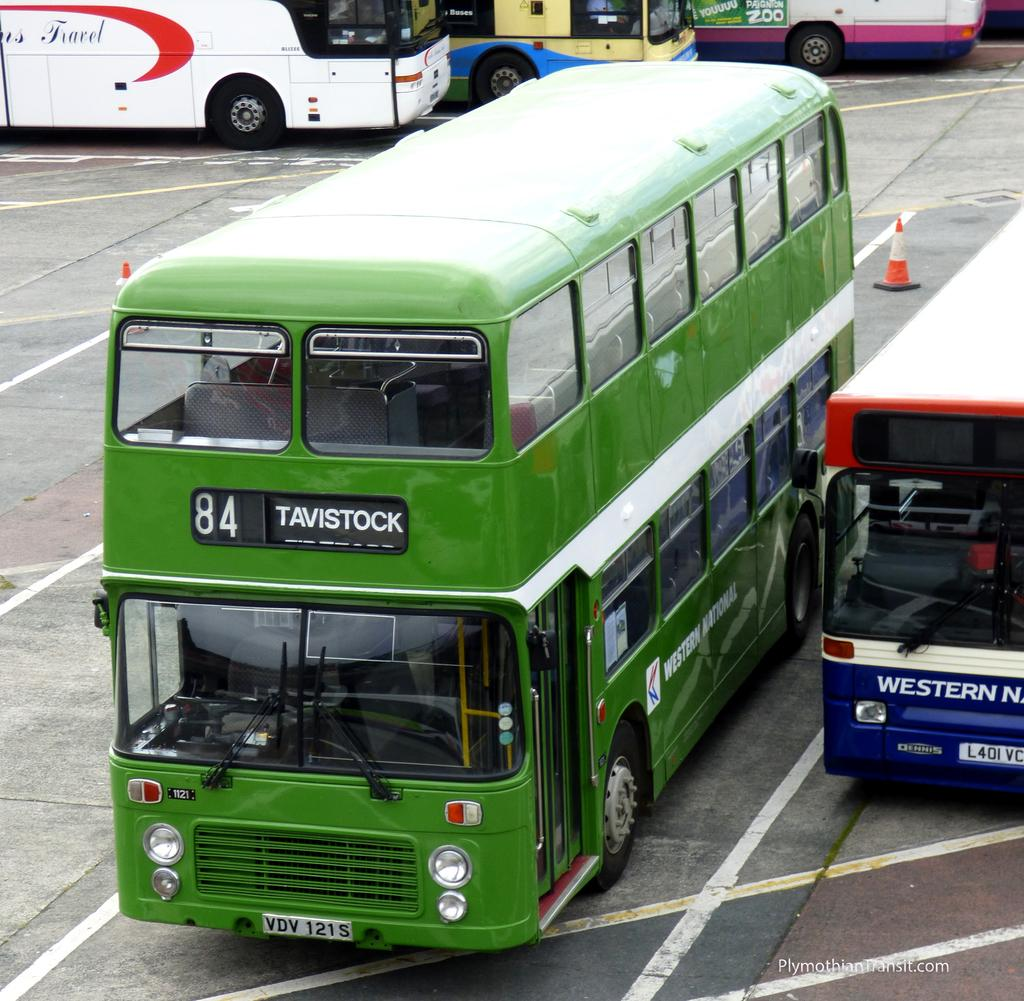What type of vehicles can be seen in the image? There are buses in the image. Can you describe one of the buses in more detail? Yes, there is a green double-decker bus in the image. What type of steel is used to construct the bubble in the image? There is no bubble present in the image, so it is not possible to determine the type of steel used for its construction. 